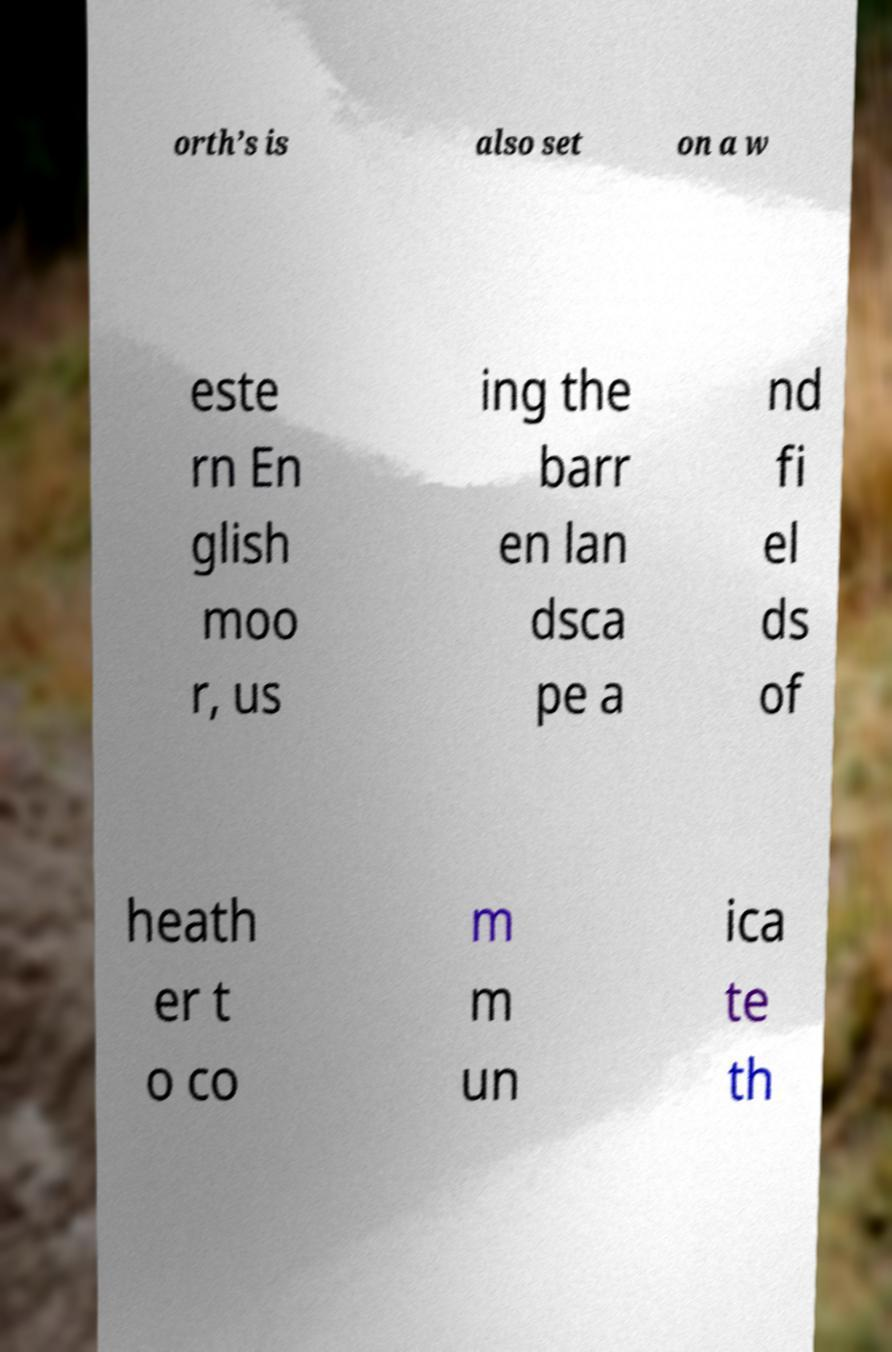Could you extract and type out the text from this image? orth’s is also set on a w este rn En glish moo r, us ing the barr en lan dsca pe a nd fi el ds of heath er t o co m m un ica te th 